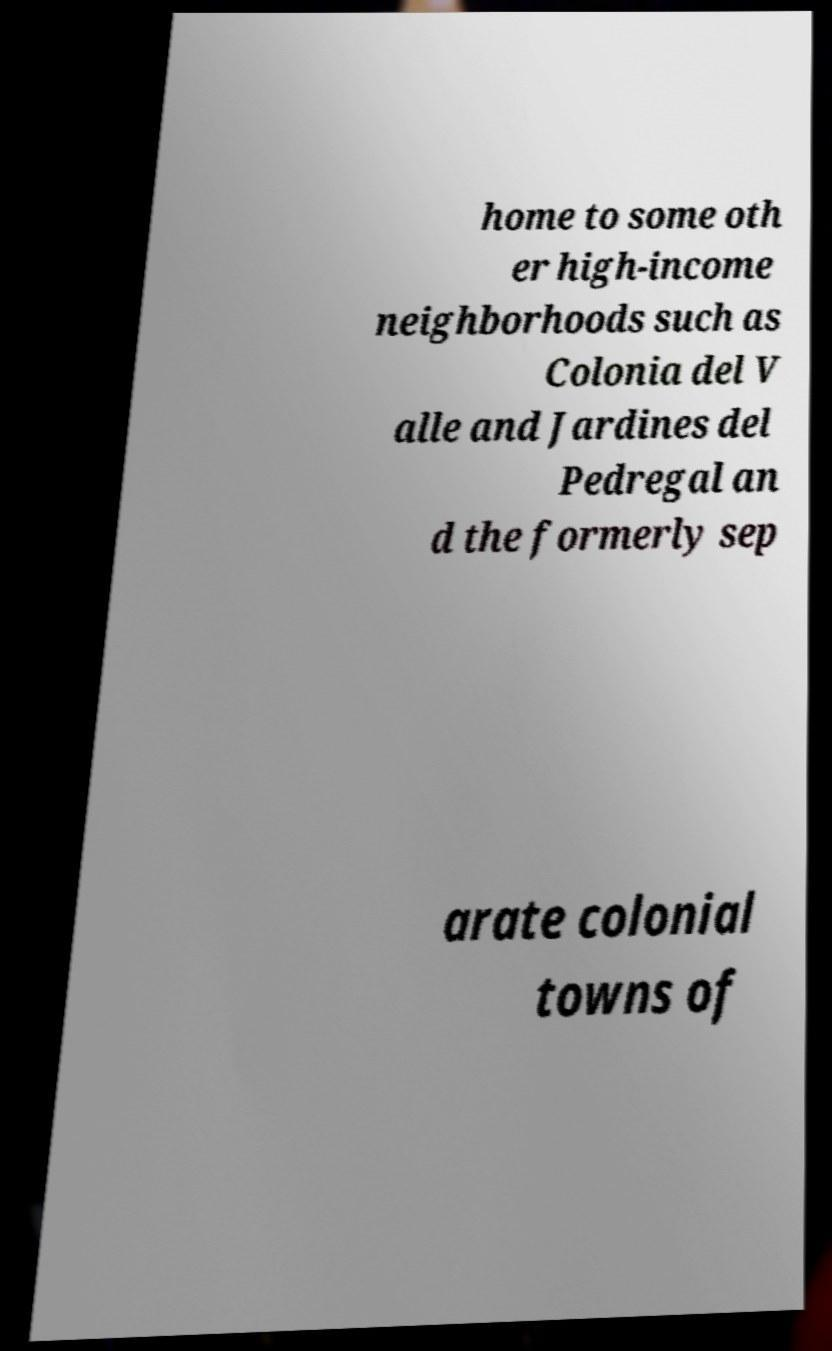There's text embedded in this image that I need extracted. Can you transcribe it verbatim? home to some oth er high-income neighborhoods such as Colonia del V alle and Jardines del Pedregal an d the formerly sep arate colonial towns of 